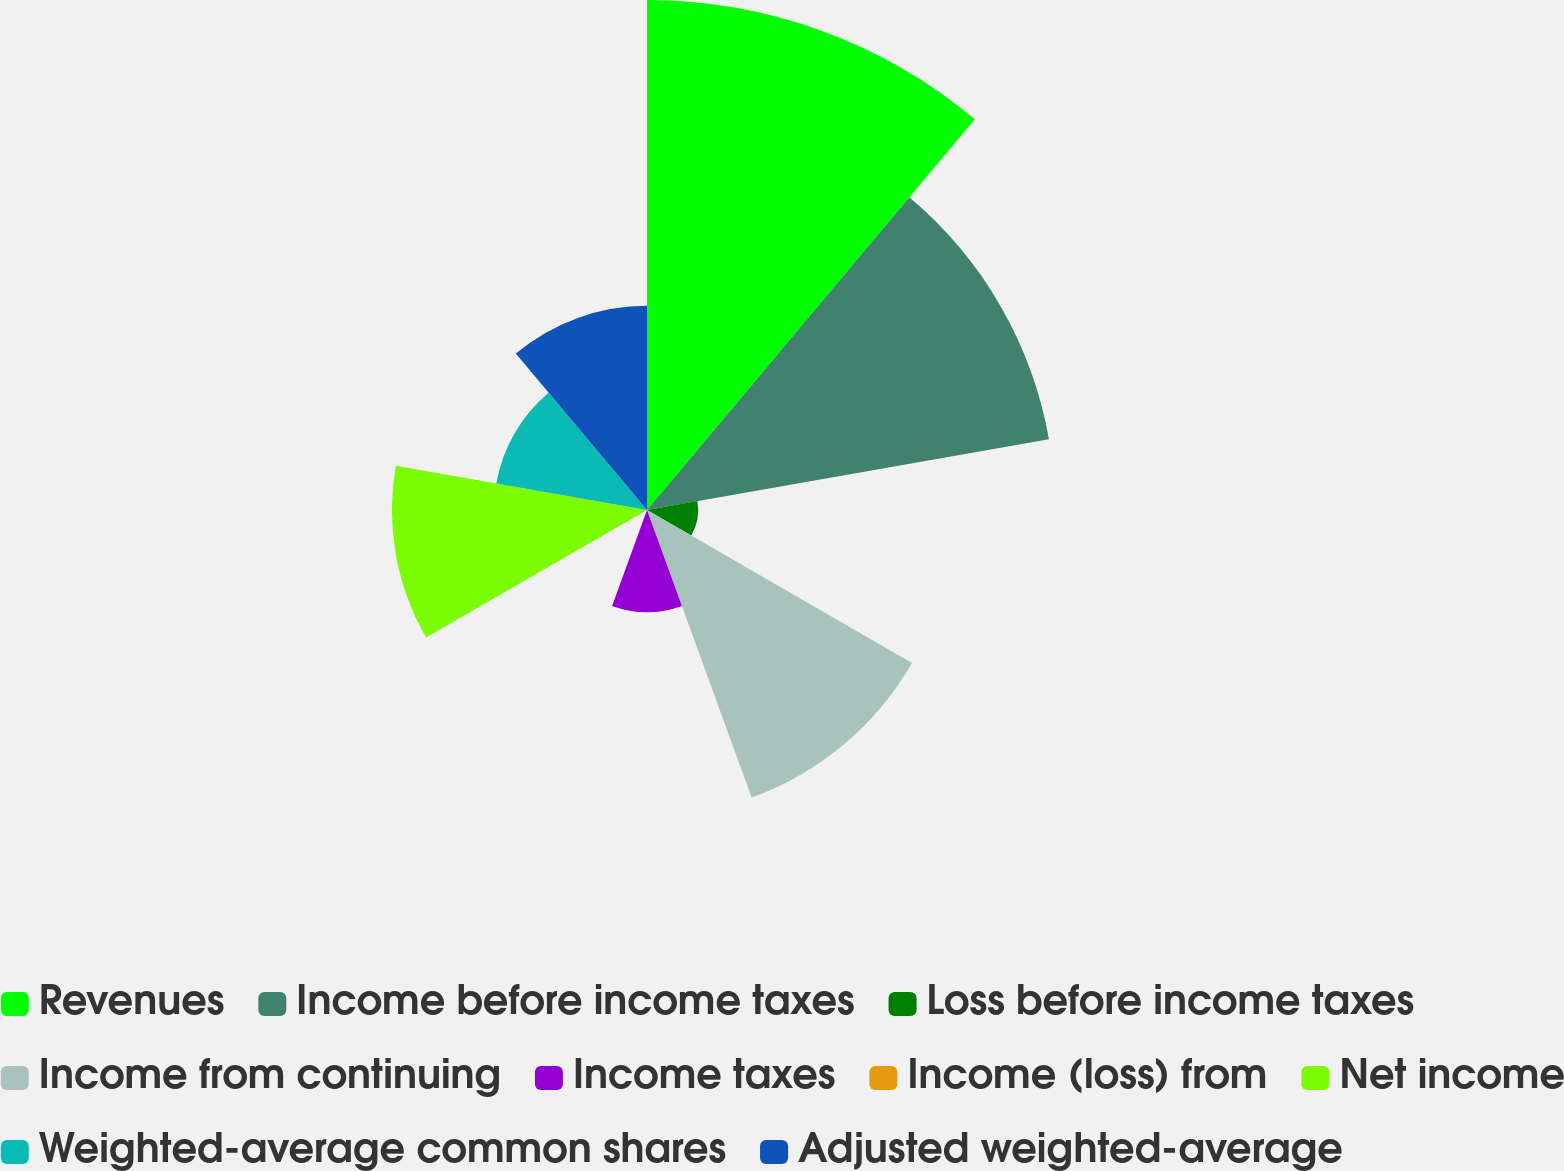Convert chart. <chart><loc_0><loc_0><loc_500><loc_500><pie_chart><fcel>Revenues<fcel>Income before income taxes<fcel>Loss before income taxes<fcel>Income from continuing<fcel>Income taxes<fcel>Income (loss) from<fcel>Net income<fcel>Weighted-average common shares<fcel>Adjusted weighted-average<nl><fcel>25.63%<fcel>20.51%<fcel>2.57%<fcel>15.38%<fcel>5.13%<fcel>0.01%<fcel>12.82%<fcel>7.69%<fcel>10.26%<nl></chart> 